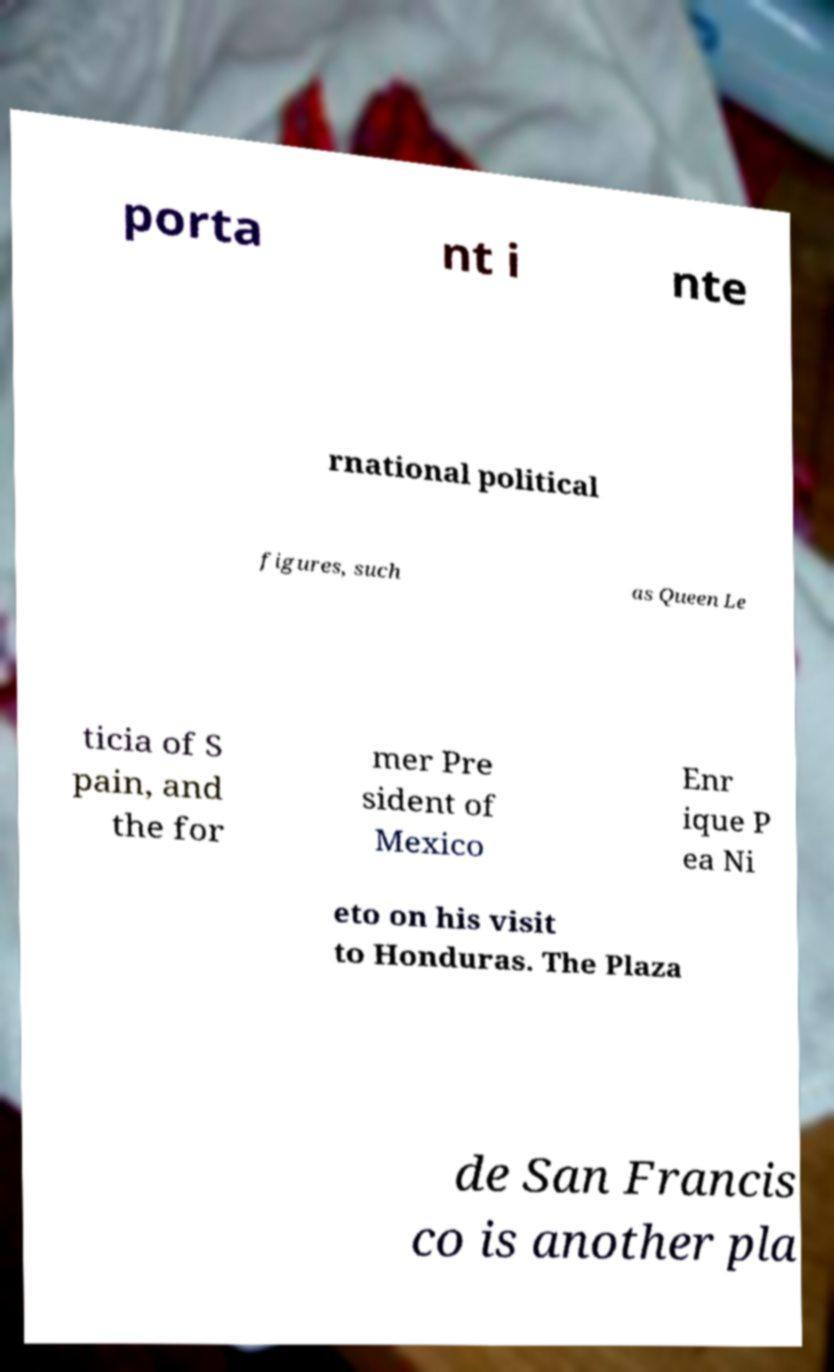Could you extract and type out the text from this image? porta nt i nte rnational political figures, such as Queen Le ticia of S pain, and the for mer Pre sident of Mexico Enr ique P ea Ni eto on his visit to Honduras. The Plaza de San Francis co is another pla 